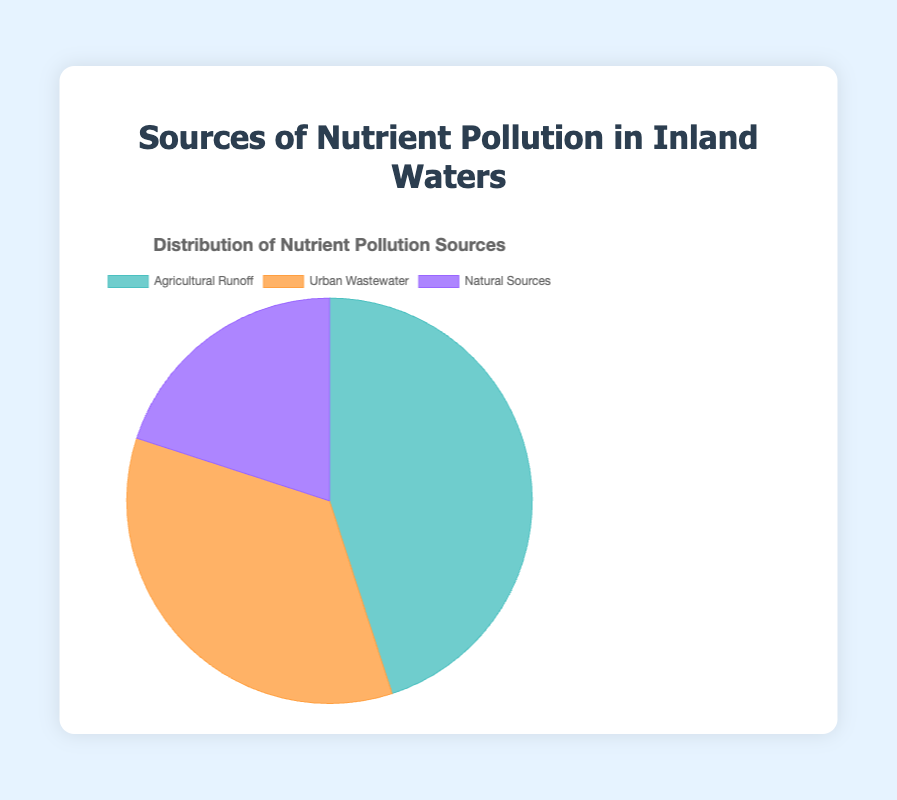What percentage of nutrient pollution comes from Urban Wastewater? The pie chart shows different segments for each source of nutrient pollution. The segment labeled "Urban Wastewater" is 35%.
Answer: 35% Which source contributes the most to nutrient pollution? By comparing the percentage values on the pie chart, we see that "Agricultural Runoff" has the highest percentage at 45%.
Answer: Agricultural Runoff How much more nutrient pollution does Agricultural Runoff contribute compared to Natural Sources? Agricultural Runoff contributes 45%, and Natural Sources contribute 20%. The difference is 45% - 20% = 25%.
Answer: 25% What is the combined percentage of nutrient pollution from Agricultural Runoff and Urban Wastewater? The percentage from Agricultural Runoff is 45%, and from Urban Wastewater is 35%. Thus, the combined percentage is 45% + 35% = 80%.
Answer: 80% If Natural Sources were to increase by 10%, how would that compare to the current percentage from Urban Wastewater? If Natural Sources increase by 10%, the new percentage would be 20% + 10% = 30%. This is still less than the current 35% from Urban Wastewater.
Answer: Urban Wastewater would still be higher What source is represented by the purple color in the chart? By examining the visual attributes in the pie chart, the segment colored purple corresponds to Natural Sources.
Answer: Natural Sources Rank the sources of nutrient pollution in descending order of their contributions. Based on the percentages in the pie chart: Agricultural Runoff (45%), Urban Wastewater (35%), Natural Sources (20%).
Answer: Agricultural Runoff, Urban Wastewater, Natural Sources Considering the provided data, what can be inferred about the dominant specific source of each main pollution category? For Agricultural Runoff, crop fields (25%). For Urban Wastewater, residential sewage (20%). For Natural Sources, soil erosion (10%).
Answer: Crop fields, residential sewage, soil erosion Which two sources combined make up more than two-thirds of the total nutrient pollution? Combining the percentages of Agricultural Runoff (45%) and Urban Wastewater (35%) gives 45% + 35% = 80%, which is more than two-thirds (66.67%) of the total.
Answer: Agricultural Runoff and Urban Wastewater 